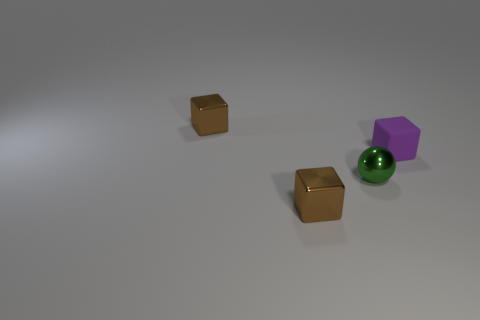Is there any other thing that is the same shape as the green metal object?
Ensure brevity in your answer.  No. The rubber object has what shape?
Give a very brief answer. Cube. What material is the block that is in front of the shiny sphere?
Offer a terse response. Metal. How many objects are either things in front of the small purple thing or tiny metal objects behind the purple matte thing?
Make the answer very short. 3. What is the color of the object that is behind the ball and on the left side of the matte block?
Offer a terse response. Brown. Are there more tiny matte objects than yellow objects?
Your answer should be very brief. Yes. There is a shiny object that is in front of the small shiny ball; does it have the same shape as the green shiny object?
Offer a terse response. No. How many matte things are small brown things or green balls?
Offer a very short reply. 0. Is there a big cyan object that has the same material as the green ball?
Ensure brevity in your answer.  No. What material is the green sphere?
Your answer should be compact. Metal. 